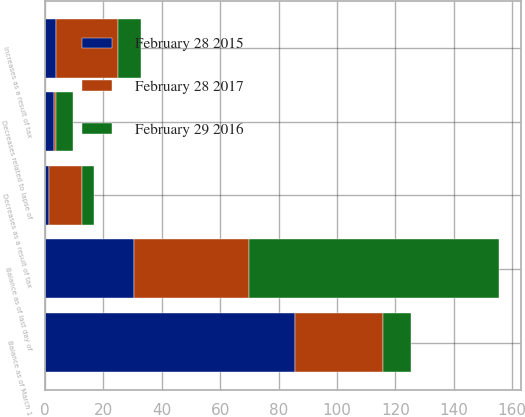Convert chart to OTSL. <chart><loc_0><loc_0><loc_500><loc_500><stacked_bar_chart><ecel><fcel>Balance as of March 1<fcel>Decreases as a result of tax<fcel>Increases as a result of tax<fcel>Decreases related to lapse of<fcel>Balance as of last day of<nl><fcel>February 28 2017<fcel>30.4<fcel>11.5<fcel>21.3<fcel>0.7<fcel>39.5<nl><fcel>February 28 2015<fcel>85.5<fcel>1.2<fcel>3.7<fcel>3<fcel>30.4<nl><fcel>February 29 2016<fcel>9.6<fcel>4<fcel>7.7<fcel>5.9<fcel>85.5<nl></chart> 